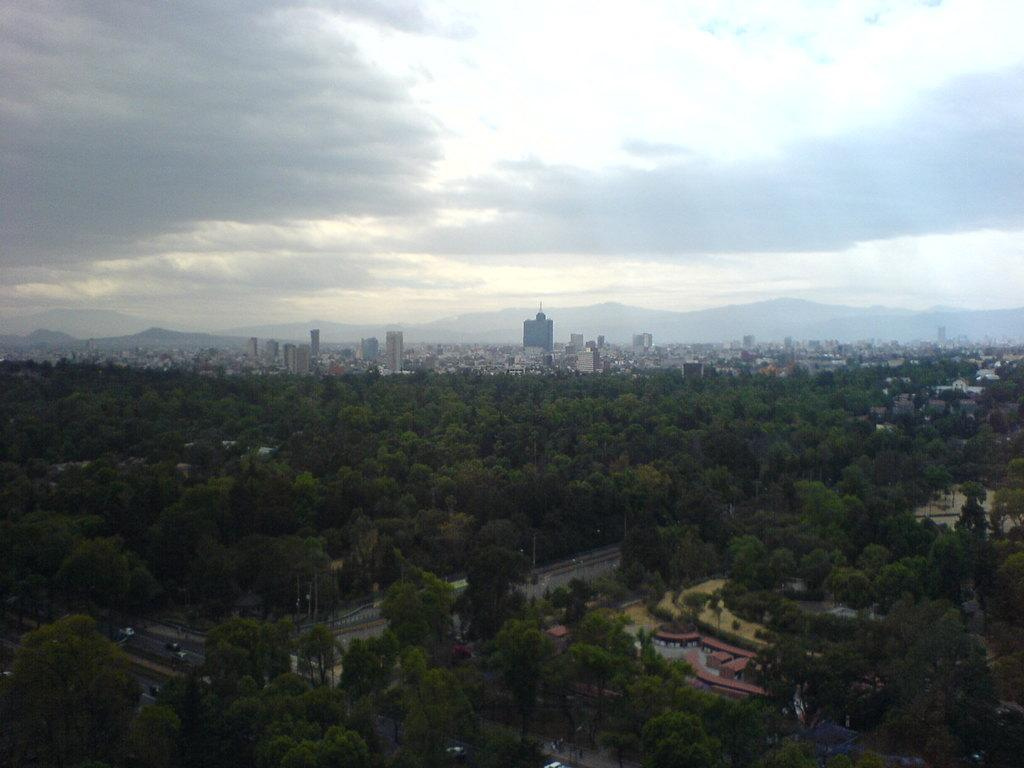What type of natural elements can be seen in the image? There are trees in the image. What type of man-made structures are present in the image? There are buildings and tower buildings in the image. What type of geographical feature can be seen in the image? There are hills in the image. What is visible in the sky in the image? There are clouds in the sky in the image. What type of transportation is visible in the image? There are vehicles on the road in the image. Can you see the mouth of the building in the image? There is no mouth present on the buildings in the image, as buildings do not have mouths. How many doors are visible on the trees in the image? There are no doors present on the trees in the image, as trees do not have doors. 